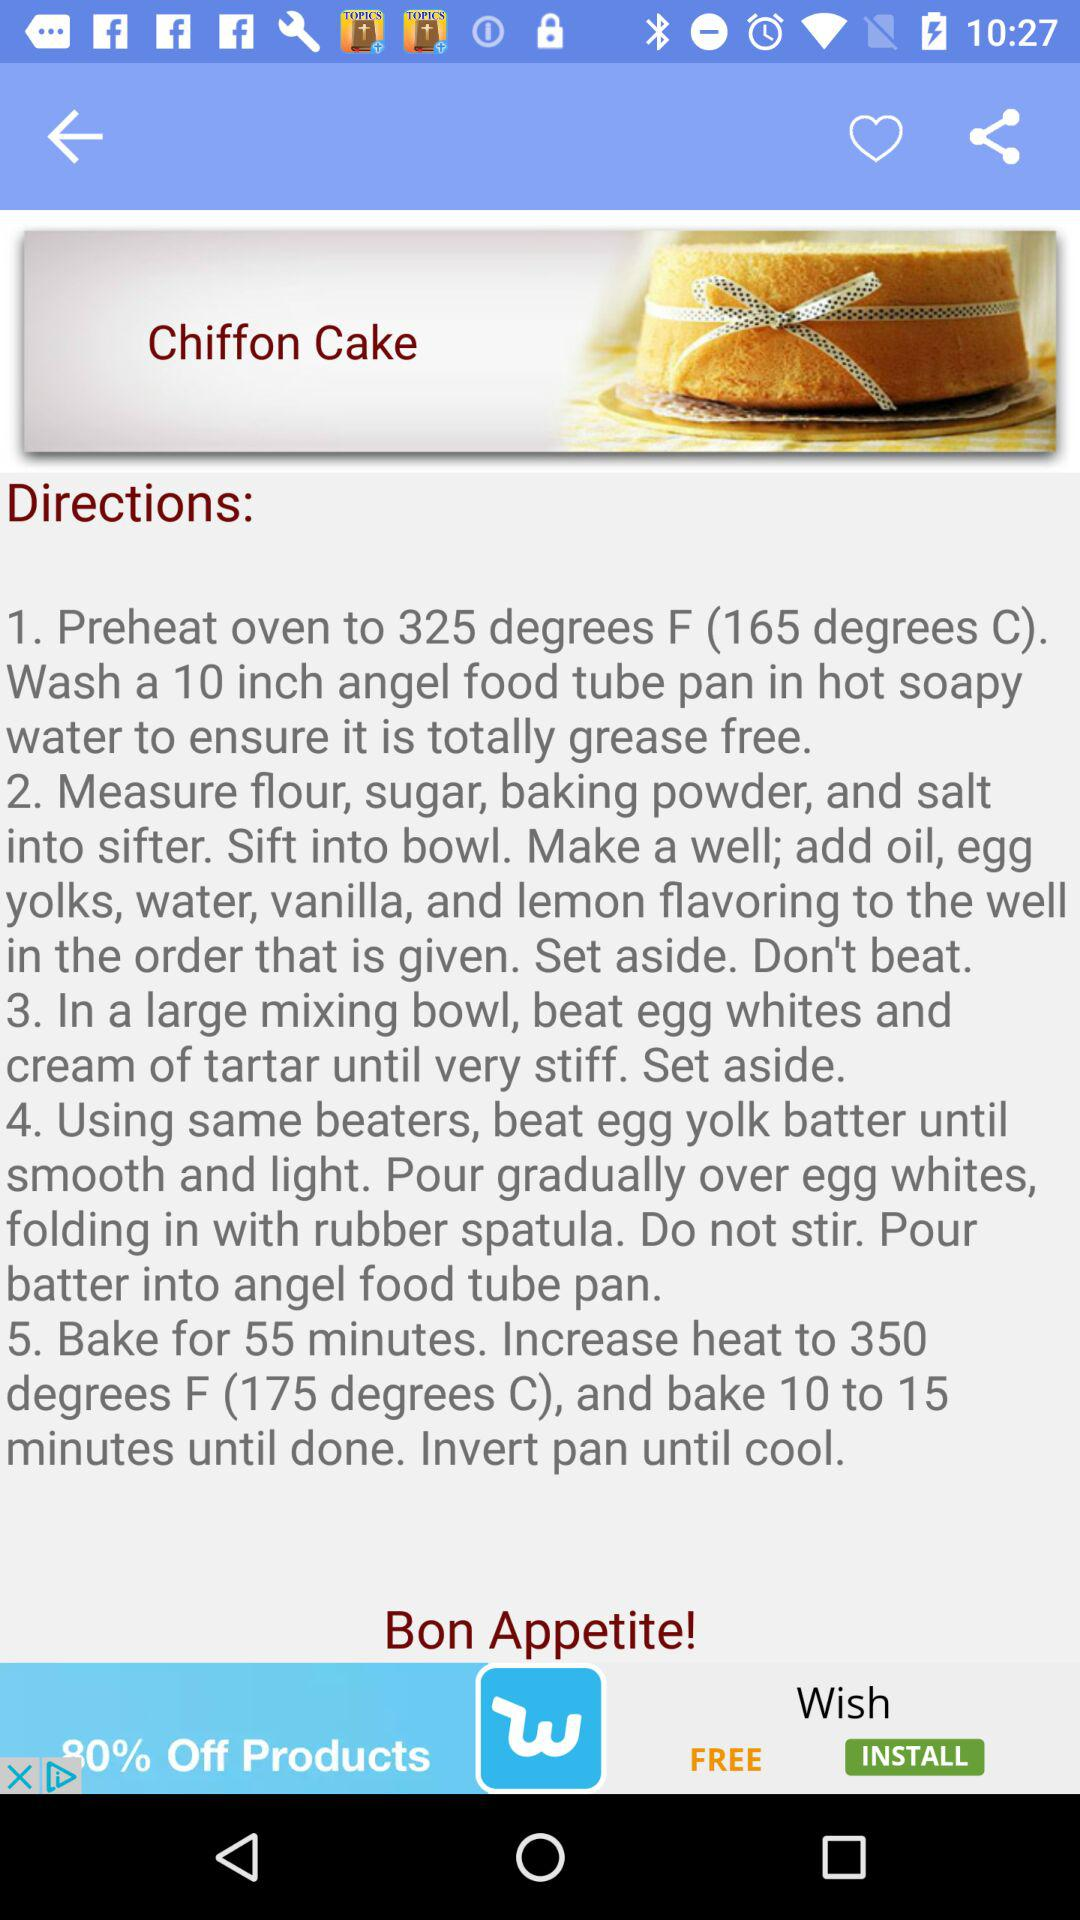What is the preheat temperature for the oven? The preheat temperature is 325 degrees F (165 degrees C). 